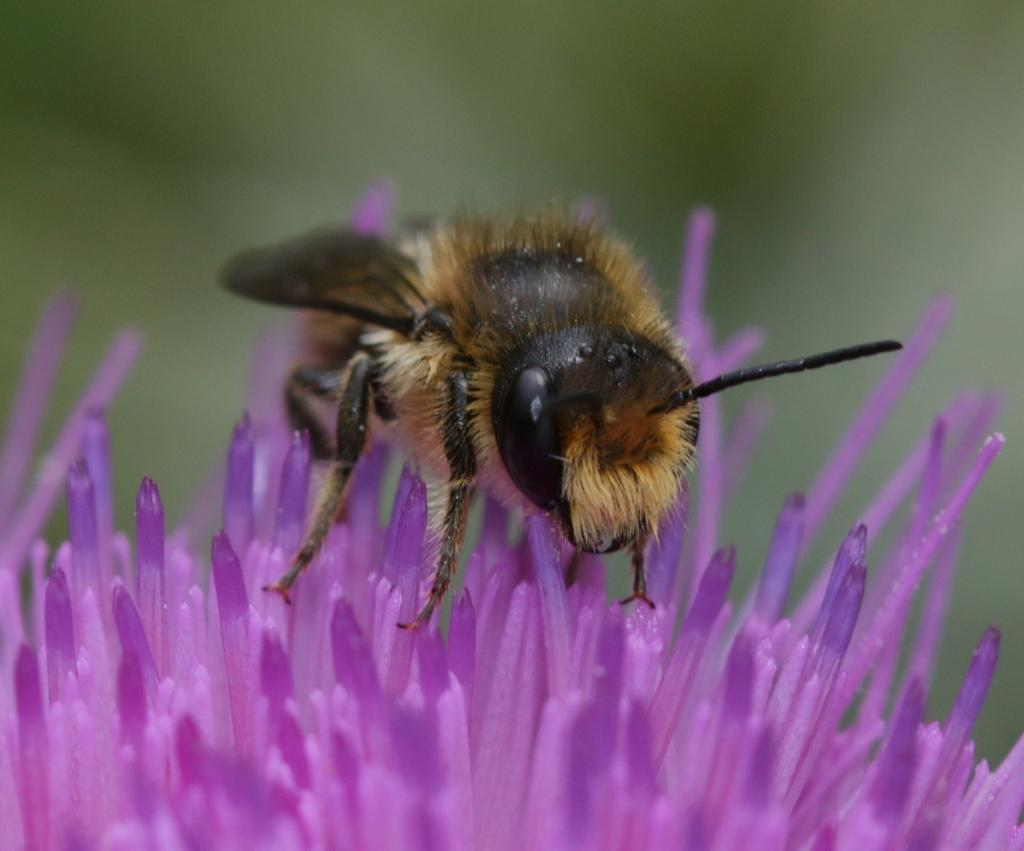What is present in the image? There is an insect in the image. Where is the insect located? The insect is on a flower. Can you describe the background of the image? The background of the image is blurred. What scent is the insect emitting in the image? There is no information about the insect's scent in the image, so it cannot be determined. 